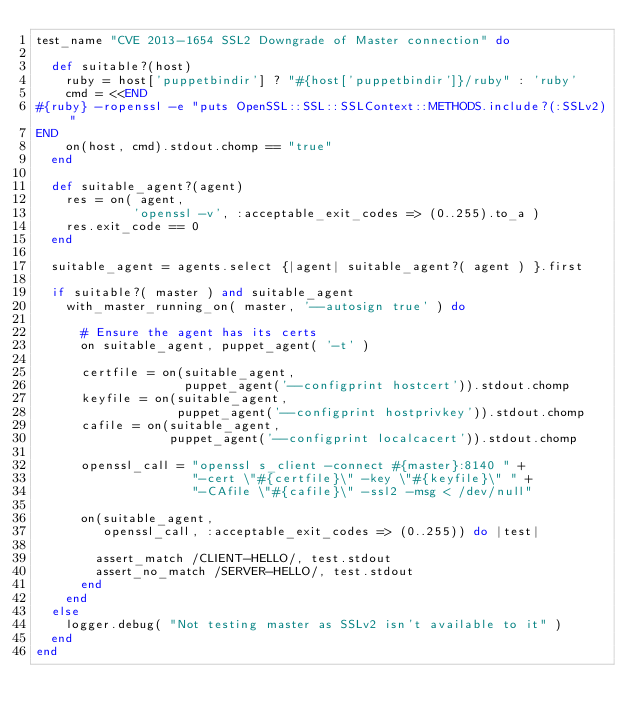Convert code to text. <code><loc_0><loc_0><loc_500><loc_500><_Ruby_>test_name "CVE 2013-1654 SSL2 Downgrade of Master connection" do

  def suitable?(host)
    ruby = host['puppetbindir'] ? "#{host['puppetbindir']}/ruby" : 'ruby'
    cmd = <<END
#{ruby} -ropenssl -e "puts OpenSSL::SSL::SSLContext::METHODS.include?(:SSLv2)"
END
    on(host, cmd).stdout.chomp == "true"
  end

  def suitable_agent?(agent)
    res = on( agent,
             'openssl -v', :acceptable_exit_codes => (0..255).to_a )
    res.exit_code == 0
  end

  suitable_agent = agents.select {|agent| suitable_agent?( agent ) }.first

  if suitable?( master ) and suitable_agent
    with_master_running_on( master, '--autosign true' ) do

      # Ensure the agent has its certs
      on suitable_agent, puppet_agent( '-t' )

      certfile = on(suitable_agent,
                    puppet_agent('--configprint hostcert')).stdout.chomp
      keyfile = on(suitable_agent,
                   puppet_agent('--configprint hostprivkey')).stdout.chomp
      cafile = on(suitable_agent,
                  puppet_agent('--configprint localcacert')).stdout.chomp

      openssl_call = "openssl s_client -connect #{master}:8140 " +
                     "-cert \"#{certfile}\" -key \"#{keyfile}\" " +
                     "-CAfile \"#{cafile}\" -ssl2 -msg < /dev/null"

      on(suitable_agent,
         openssl_call, :acceptable_exit_codes => (0..255)) do |test|

        assert_match /CLIENT-HELLO/, test.stdout
        assert_no_match /SERVER-HELLO/, test.stdout
      end
    end
  else
    logger.debug( "Not testing master as SSLv2 isn't available to it" )
  end
end
</code> 